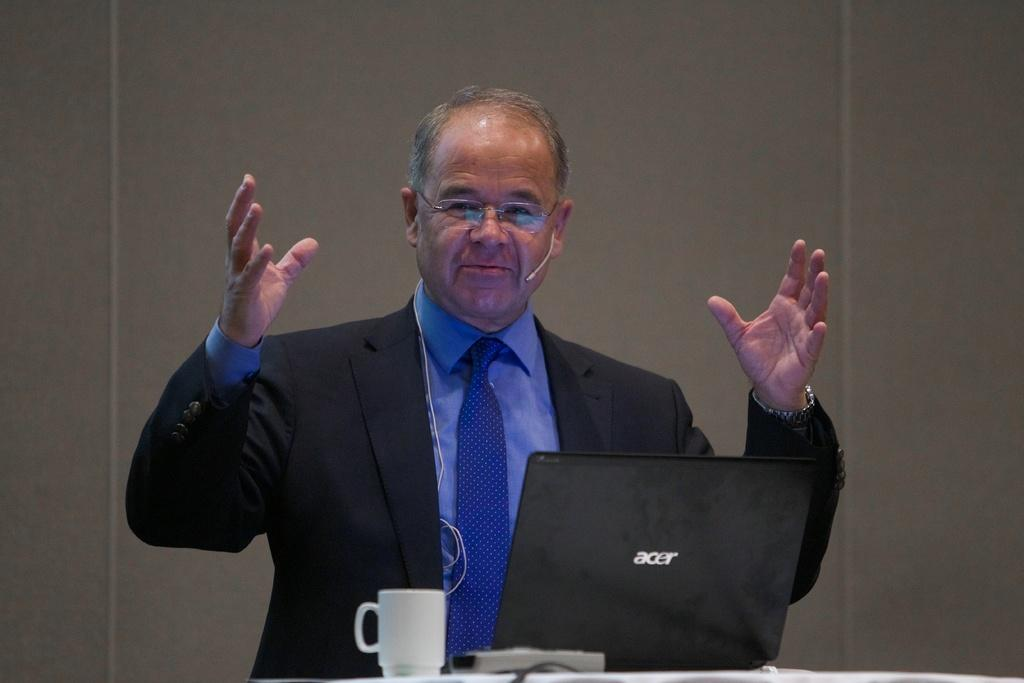What is the main subject in the middle of the image? There is a person, a laptop, a remote, and a coffee cup in the middle of the image. What objects might the person be using in the image? The person might be using the laptop and the remote in the image. What is visible in the background of the image? There is a wall in the background of the image. How many ducks are present in the image? There are no ducks present in the image. What type of yoke is being used by the person in the image? There is no yoke present in the image, and the person is not using any yoke. 